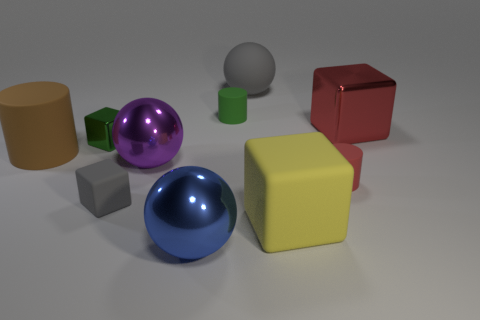What material is the blue ball that is the same size as the yellow cube?
Your answer should be compact. Metal. Are there any matte blocks of the same size as the blue ball?
Keep it short and to the point. Yes. Does the big sphere behind the large red metallic cube have the same color as the rubber cube left of the large rubber block?
Provide a succinct answer. Yes. How many metallic objects are small red spheres or purple things?
Offer a terse response. 1. There is a tiny rubber thing left of the big shiny sphere that is in front of the big purple ball; how many big brown rubber cylinders are to the left of it?
Provide a succinct answer. 1. What size is the other ball that is made of the same material as the large purple sphere?
Provide a short and direct response. Large. How many matte objects have the same color as the large matte ball?
Your answer should be very brief. 1. There is a gray rubber object that is left of the blue shiny ball; does it have the same size as the gray rubber sphere?
Provide a succinct answer. No. There is a rubber cylinder that is right of the small metallic block and on the left side of the big gray matte object; what color is it?
Keep it short and to the point. Green. What number of things are either large rubber things or metallic things in front of the purple metal ball?
Keep it short and to the point. 4. 